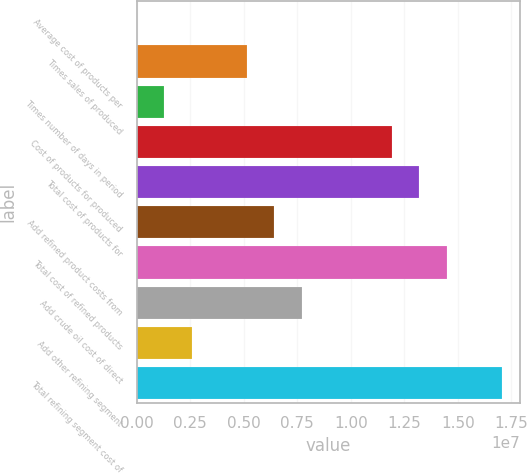Convert chart to OTSL. <chart><loc_0><loc_0><loc_500><loc_500><bar_chart><fcel>Average cost of products per<fcel>Times sales of produced<fcel>Times number of days in period<fcel>Cost of products for produced<fcel>Total cost of products for<fcel>Add refined product costs from<fcel>Total cost of refined products<fcel>Add crude oil cost of direct<fcel>Add other refining segment<fcel>Total refining segment cost of<nl><fcel>98.18<fcel>5.13779e+06<fcel>1.28452e+06<fcel>1.19233e+07<fcel>1.32077e+07<fcel>6.42222e+06<fcel>1.44921e+07<fcel>7.70664e+06<fcel>2.56895e+06<fcel>1.70609e+07<nl></chart> 